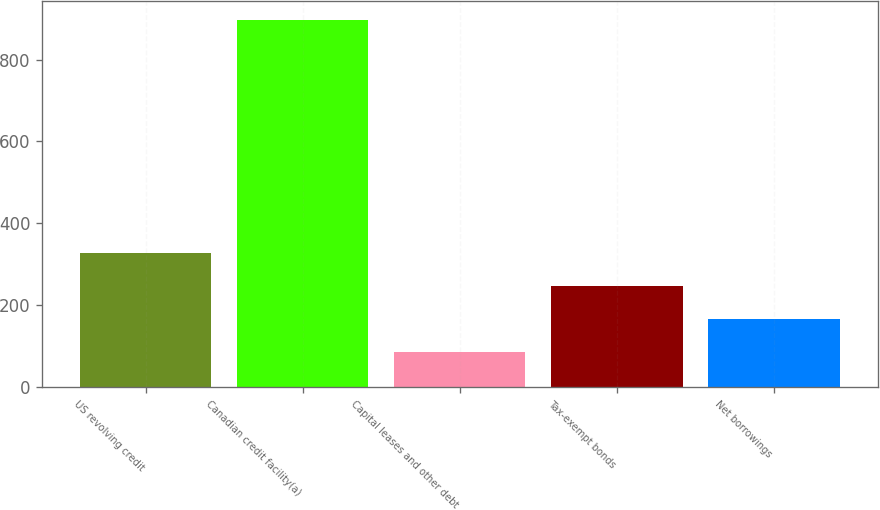<chart> <loc_0><loc_0><loc_500><loc_500><bar_chart><fcel>US revolving credit<fcel>Canadian credit facility(a)<fcel>Capital leases and other debt<fcel>Tax-exempt bonds<fcel>Net borrowings<nl><fcel>328.6<fcel>897<fcel>85<fcel>247.4<fcel>166.2<nl></chart> 